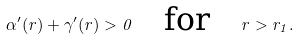<formula> <loc_0><loc_0><loc_500><loc_500>\alpha ^ { \prime } ( r ) + \gamma ^ { \prime } ( r ) > 0 \quad \text {for} \quad r > r _ { 1 } .</formula> 